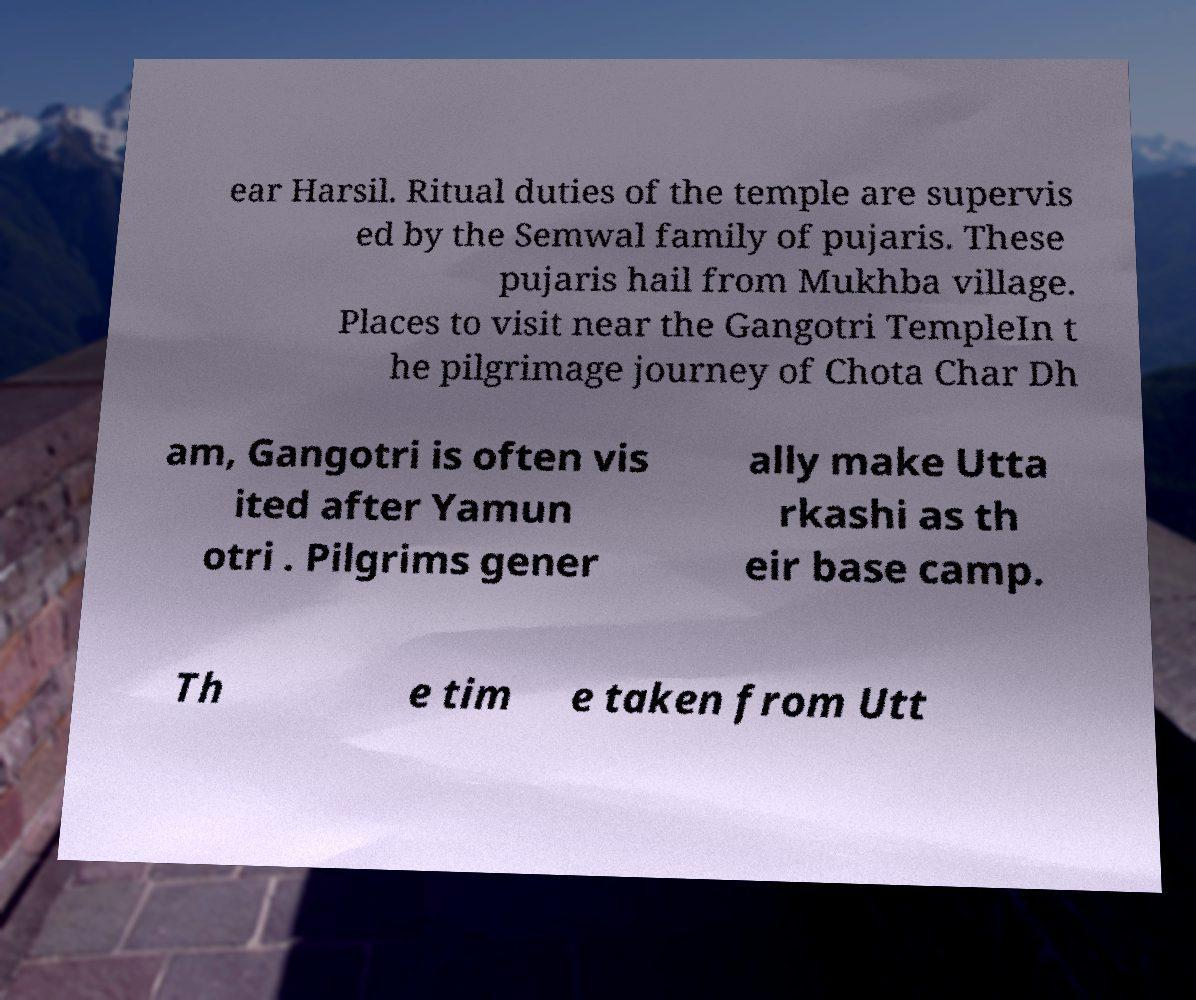There's text embedded in this image that I need extracted. Can you transcribe it verbatim? ear Harsil. Ritual duties of the temple are supervis ed by the Semwal family of pujaris. These pujaris hail from Mukhba village. Places to visit near the Gangotri TempleIn t he pilgrimage journey of Chota Char Dh am, Gangotri is often vis ited after Yamun otri . Pilgrims gener ally make Utta rkashi as th eir base camp. Th e tim e taken from Utt 